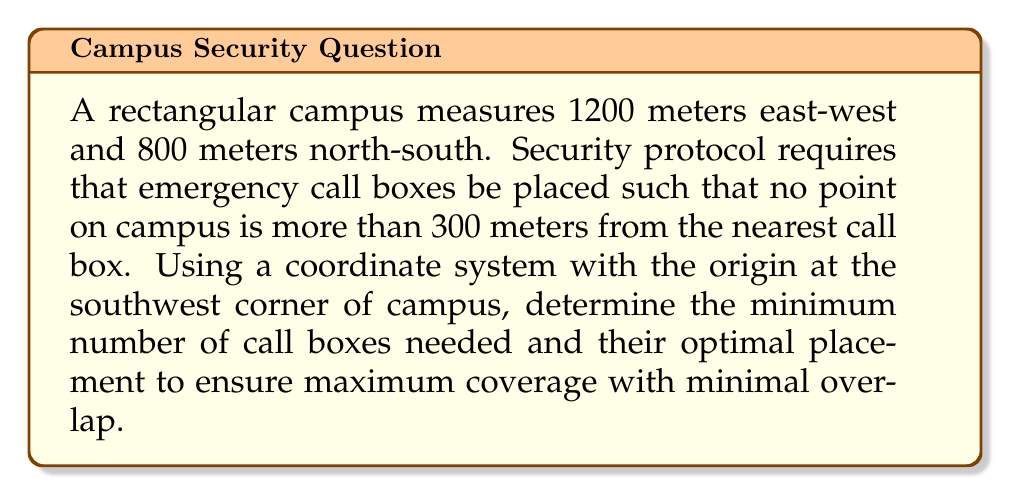Teach me how to tackle this problem. 1) First, we need to determine the area covered by each call box. The coverage area is circular with a radius of 300 meters.

   Area of coverage = $\pi r^2 = \pi (300)^2 = 282,743.34$ square meters

2) The total area of the campus is:
   
   $1200 \text{ m} \times 800 \text{ m} = 960,000$ square meters

3) Theoretically, the minimum number of call boxes needed would be:

   $960,000 \div 282,743.34 = 3.39$

   However, we need to round up to ensure full coverage, so we need at least 4 call boxes.

4) To optimize placement, we should position the call boxes in a grid pattern. The optimal grid would be 2x2.

5) To determine the exact coordinates, we need to divide the campus into four equal rectangles:

   East-west: $1200 \div 2 = 600$ meters
   North-south: $800 \div 2 = 400$ meters

6) The centers of these rectangles will be the optimal positions for the call boxes:

   Box 1: $(300, 200)$
   Box 2: $(900, 200)$
   Box 3: $(300, 600)$
   Box 4: $(900, 600)$

7) To verify coverage, we can check the corners of the campus:

   Southwest $(0,0)$: Distance to Box 1 = $\sqrt{300^2 + 200^2} = 360.56$ m
   Southeast $(1200,0)$: Distance to Box 2 = $\sqrt{300^2 + 200^2} = 360.56$ m
   Northwest $(0,800)$: Distance to Box 3 = $\sqrt{300^2 + 200^2} = 360.56$ m
   Northeast $(1200,800)$: Distance to Box 4 = $\sqrt{300^2 + 200^2} = 360.56$ m

   While these distances slightly exceed 300 m, they represent the maximum possible distance. All other points on campus will be closer to at least one call box.

[asy]
unitsize(0.1mm);
draw((0,0)--(1200,0)--(1200,800)--(0,800)--cycle);
dot((300,200),red);
dot((900,200),red);
dot((300,600),red);
dot((900,600),red);
draw(circle((300,200),300),blue);
draw(circle((900,200),300),blue);
draw(circle((300,600),300),blue);
draw(circle((900,600),300),blue);
label("(300,200)",(300,200),SE);
label("(900,200)",(900,200),SE);
label("(300,600)",(300,600),NW);
label("(900,600)",(900,600),NW);
[/asy]
Answer: 4 call boxes at $(300,200)$, $(900,200)$, $(300,600)$, $(900,600)$ 